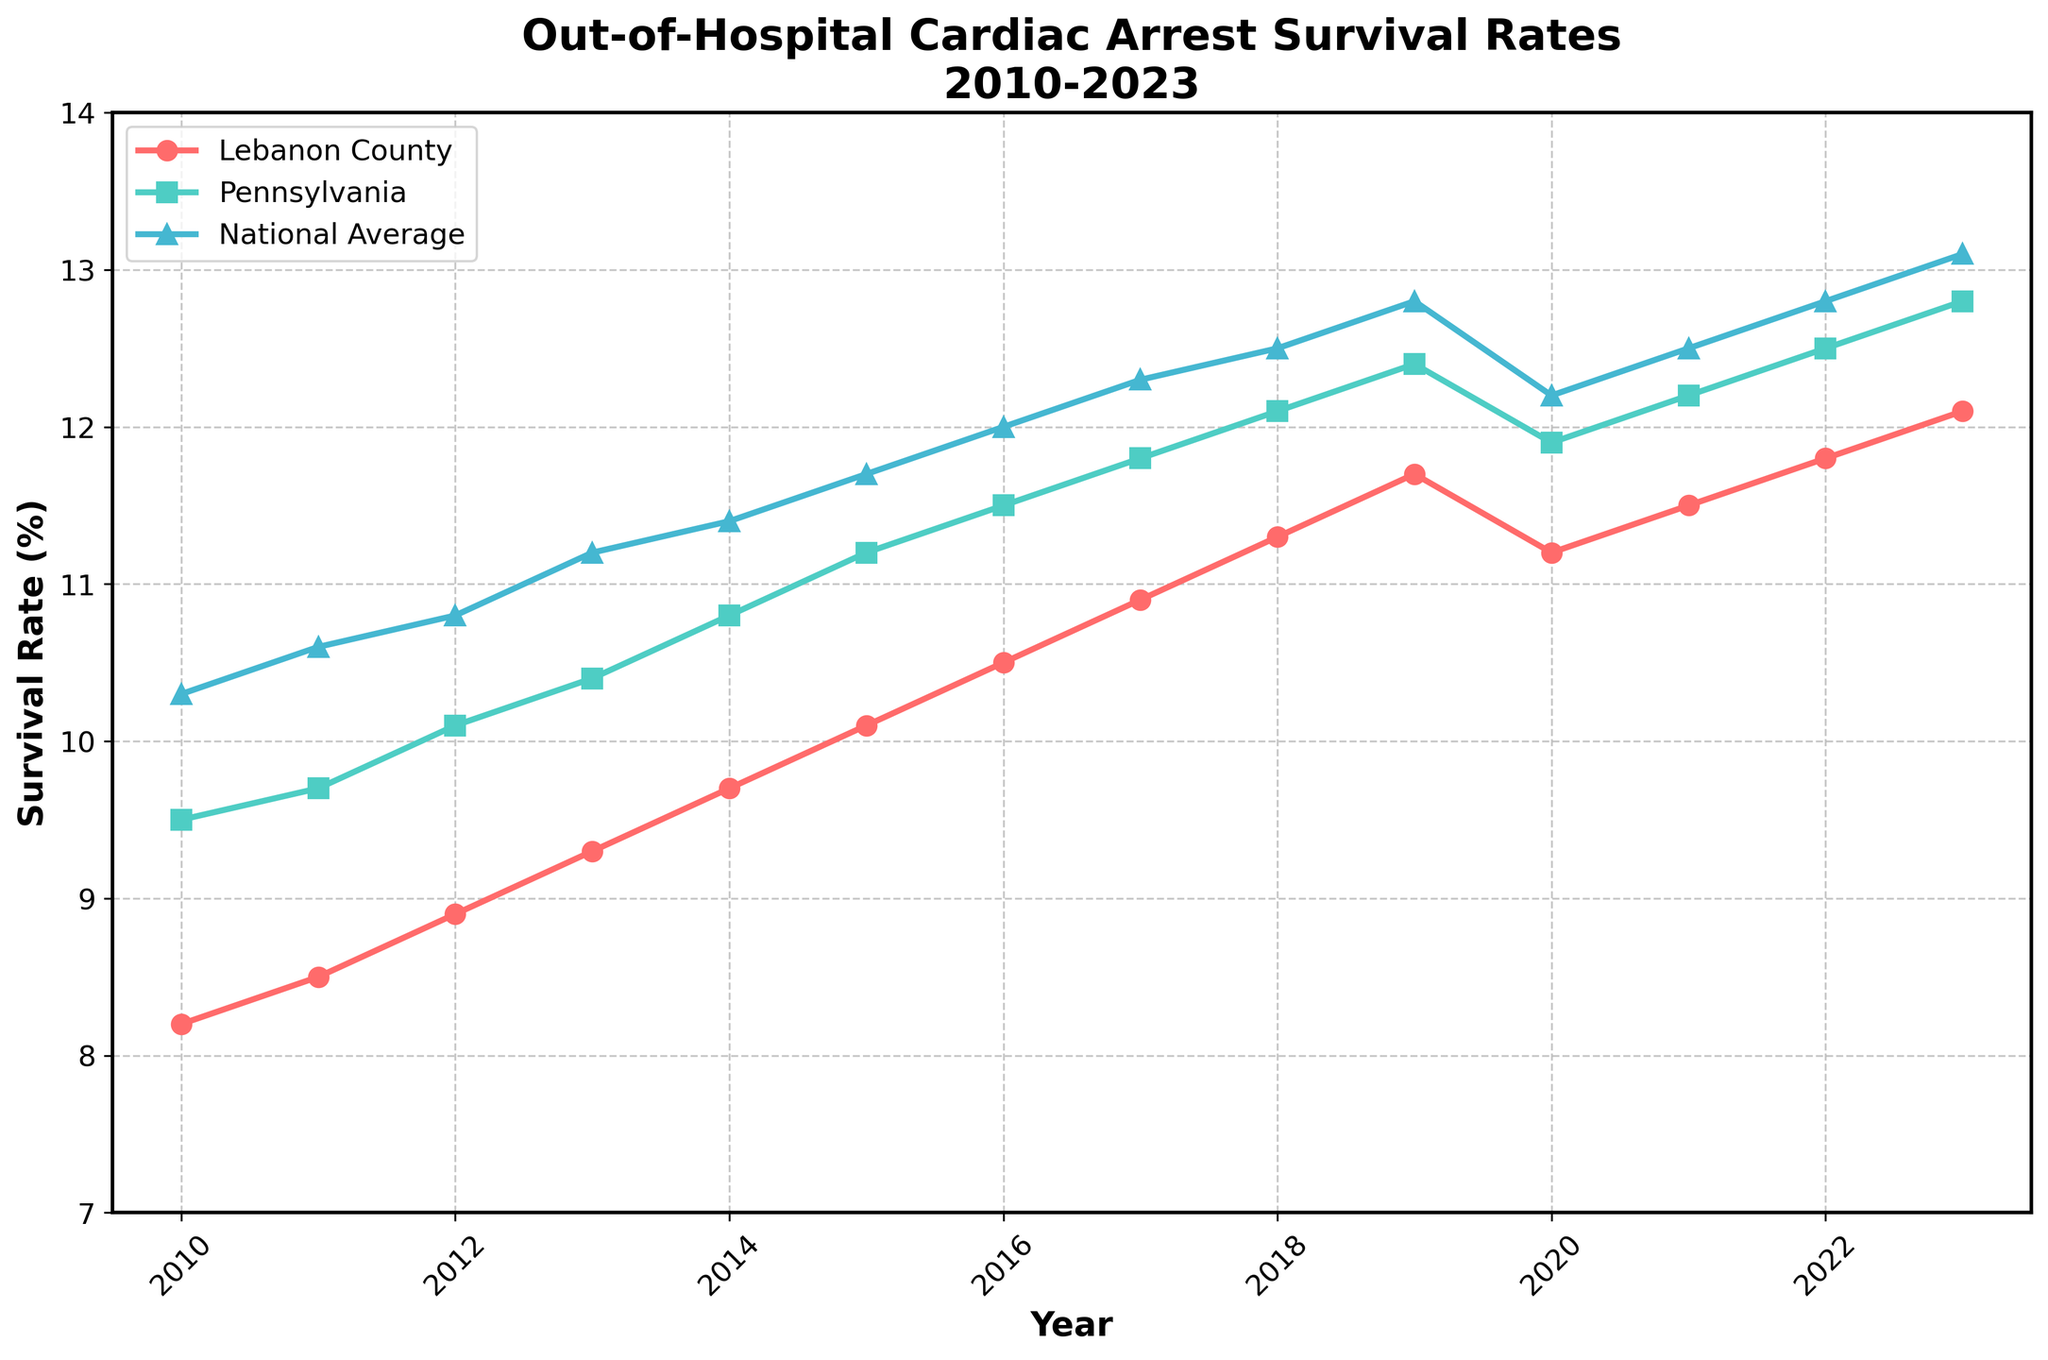What has been the general trend for the survival rate of out-of-hospital cardiac arrests in Lebanon County from 2010 to 2023? The survival rate in Lebanon County has generally increased from 8.2% in 2010 to 12.1% in 2023.
Answer: Increasing In which year did Lebanon County's survival rate see a decrease compared to the previous year? The survival rate in Lebanon County decreased in 2020, dropping from 11.7% in 2019 to 11.2% in 2020.
Answer: 2020 How does Lebanon County's survival rate in 2023 compare to the national average in the same year? In 2023, Lebanon County's survival rate was 12.1%, while the national average was 13.1%, so Lebanon County's rate was lower.
Answer: Lower Calculate the average survival rate for Lebanon County from 2010 to 2023. Summing the survival rates for Lebanon County from 2010 to 2023 (8.2 + 8.5 + 8.9 + 9.3 + 9.7 + 10.1 + 10.5 + 10.9 + 11.3 + 11.7 + 11.2 + 11.5 + 11.8 + 12.1) gives 144.8. Dividing by the number of years (14) results in an average rate of approximately 10.34%.
Answer: 10.34% In which year did Lebanon County's survival rate first surpass 10%? Lebanon County’s survival rate first surpassed 10% in the year 2015, where it reached 10.1%.
Answer: 2015 Compare the survival rates between Pennsylvania and the national average in 2016. In 2016, the survival rate for Pennsylvania was 11.5%, while the national average was 12.0%, making Pennsylvania's rate lower than the national average.
Answer: Lower Which region had the highest survival rate in 2011? In 2011, the national average had the highest survival rate at 10.6%, followed by Pennsylvania at 9.7% and Lebanon County at 8.5%.
Answer: National Average By how much did the survival rate for Lebanon County increase from 2010 to 2013? The survival rate increased from 8.2% in 2010 to 9.3% in 2013, resulting in an increase of 9.3% - 8.2% = 1.1%.
Answer: 1.1% What is the median survival rate for Lebanon County from 2010 to 2023? To find the median, list the survival rates in ascending order (8.2, 8.5, 8.9, 9.3, 9.7, 10.1, 10.5, 10.9, 11.2, 11.3, 11.5, 11.7, 11.8, 12.1). With 14 numbers, the median is the average of the 7th and 8th values: (10.5 + 10.9) / 2 = 10.7.
Answer: 10.7 